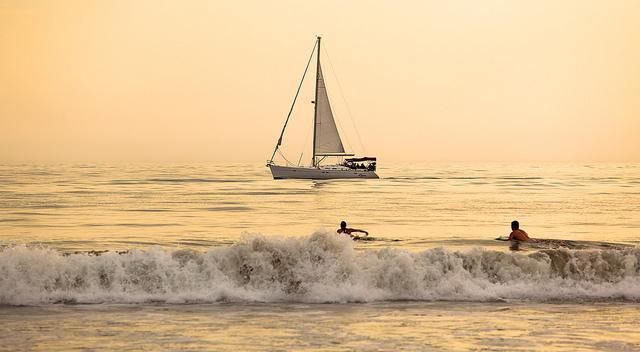What natural feature do the surfers like but the sailors of the boat here hate?
Indicate the correct response by choosing from the four available options to answer the question.
Options: Big waves, tornados, tidal wave, calm waves. Big waves. How is this boat powered?
Select the accurate response from the four choices given to answer the question.
Options: Motor, wind, whale, coal. Wind. 